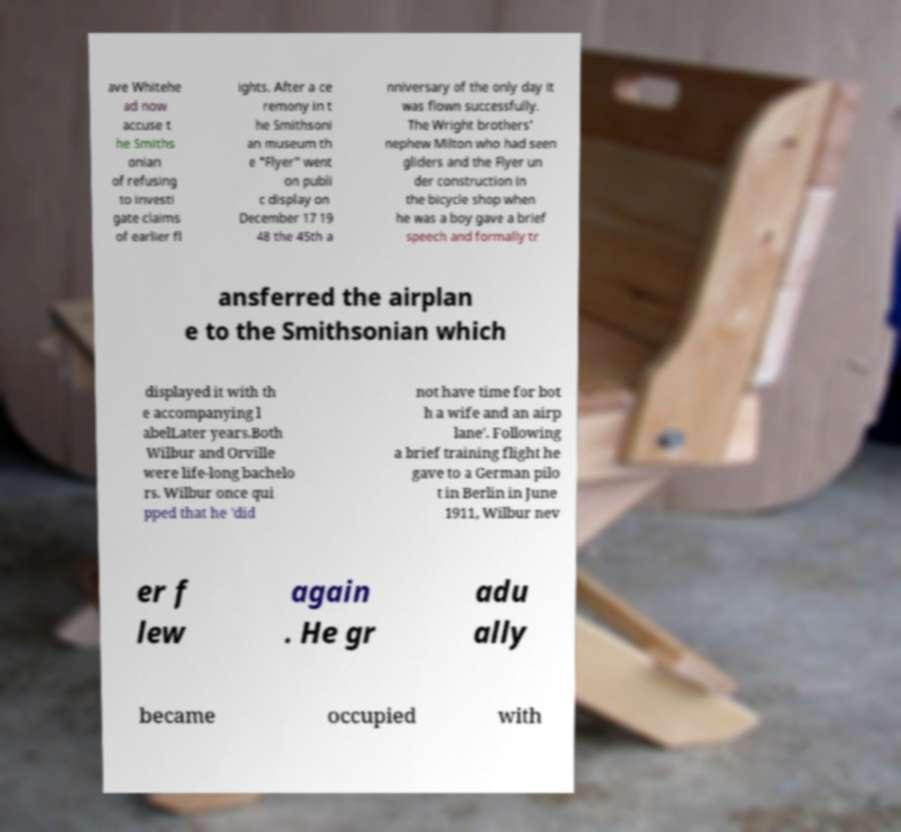Can you accurately transcribe the text from the provided image for me? ave Whitehe ad now accuse t he Smiths onian of refusing to investi gate claims of earlier fl ights. After a ce remony in t he Smithsoni an museum th e "Flyer" went on publi c display on December 17 19 48 the 45th a nniversary of the only day it was flown successfully. The Wright brothers' nephew Milton who had seen gliders and the Flyer un der construction in the bicycle shop when he was a boy gave a brief speech and formally tr ansferred the airplan e to the Smithsonian which displayed it with th e accompanying l abelLater years.Both Wilbur and Orville were life-long bachelo rs. Wilbur once qui pped that he 'did not have time for bot h a wife and an airp lane'. Following a brief training flight he gave to a German pilo t in Berlin in June 1911, Wilbur nev er f lew again . He gr adu ally became occupied with 